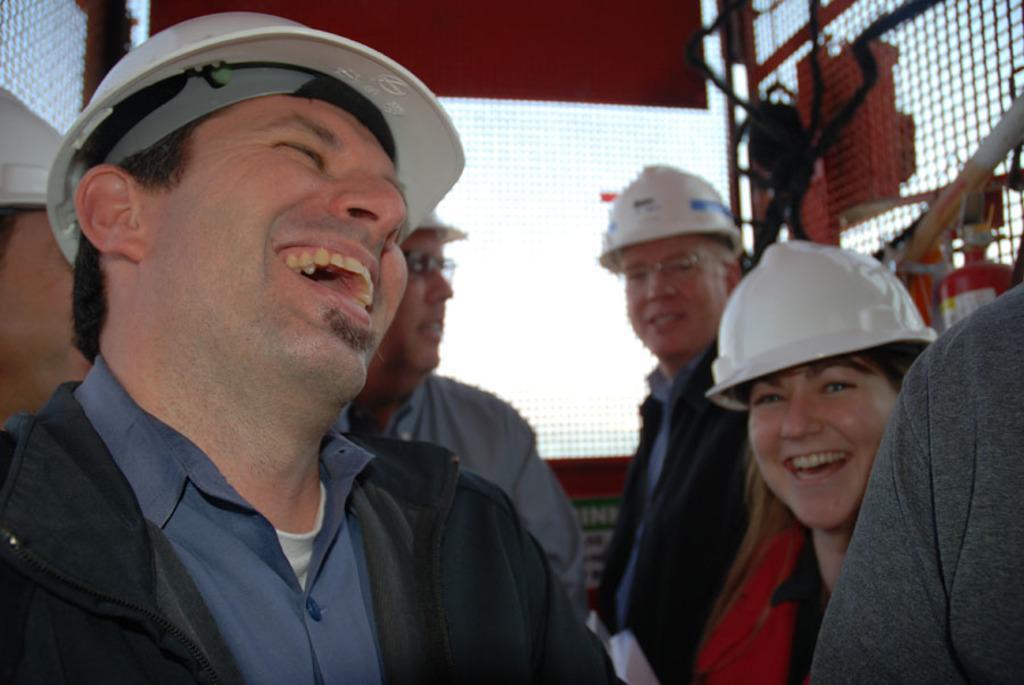In one or two sentences, can you explain what this image depicts? In the image there are a group of people, most of them are smiling and around them there are some grills made up of meshes. 